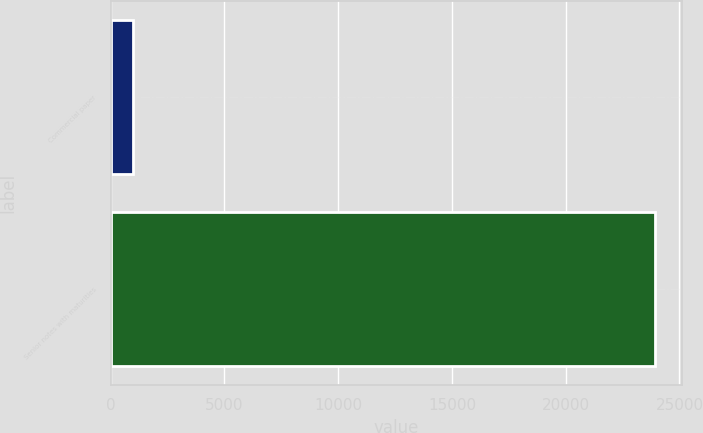<chart> <loc_0><loc_0><loc_500><loc_500><bar_chart><fcel>Commercial paper<fcel>Senior notes with maturities<nl><fcel>975<fcel>23925<nl></chart> 